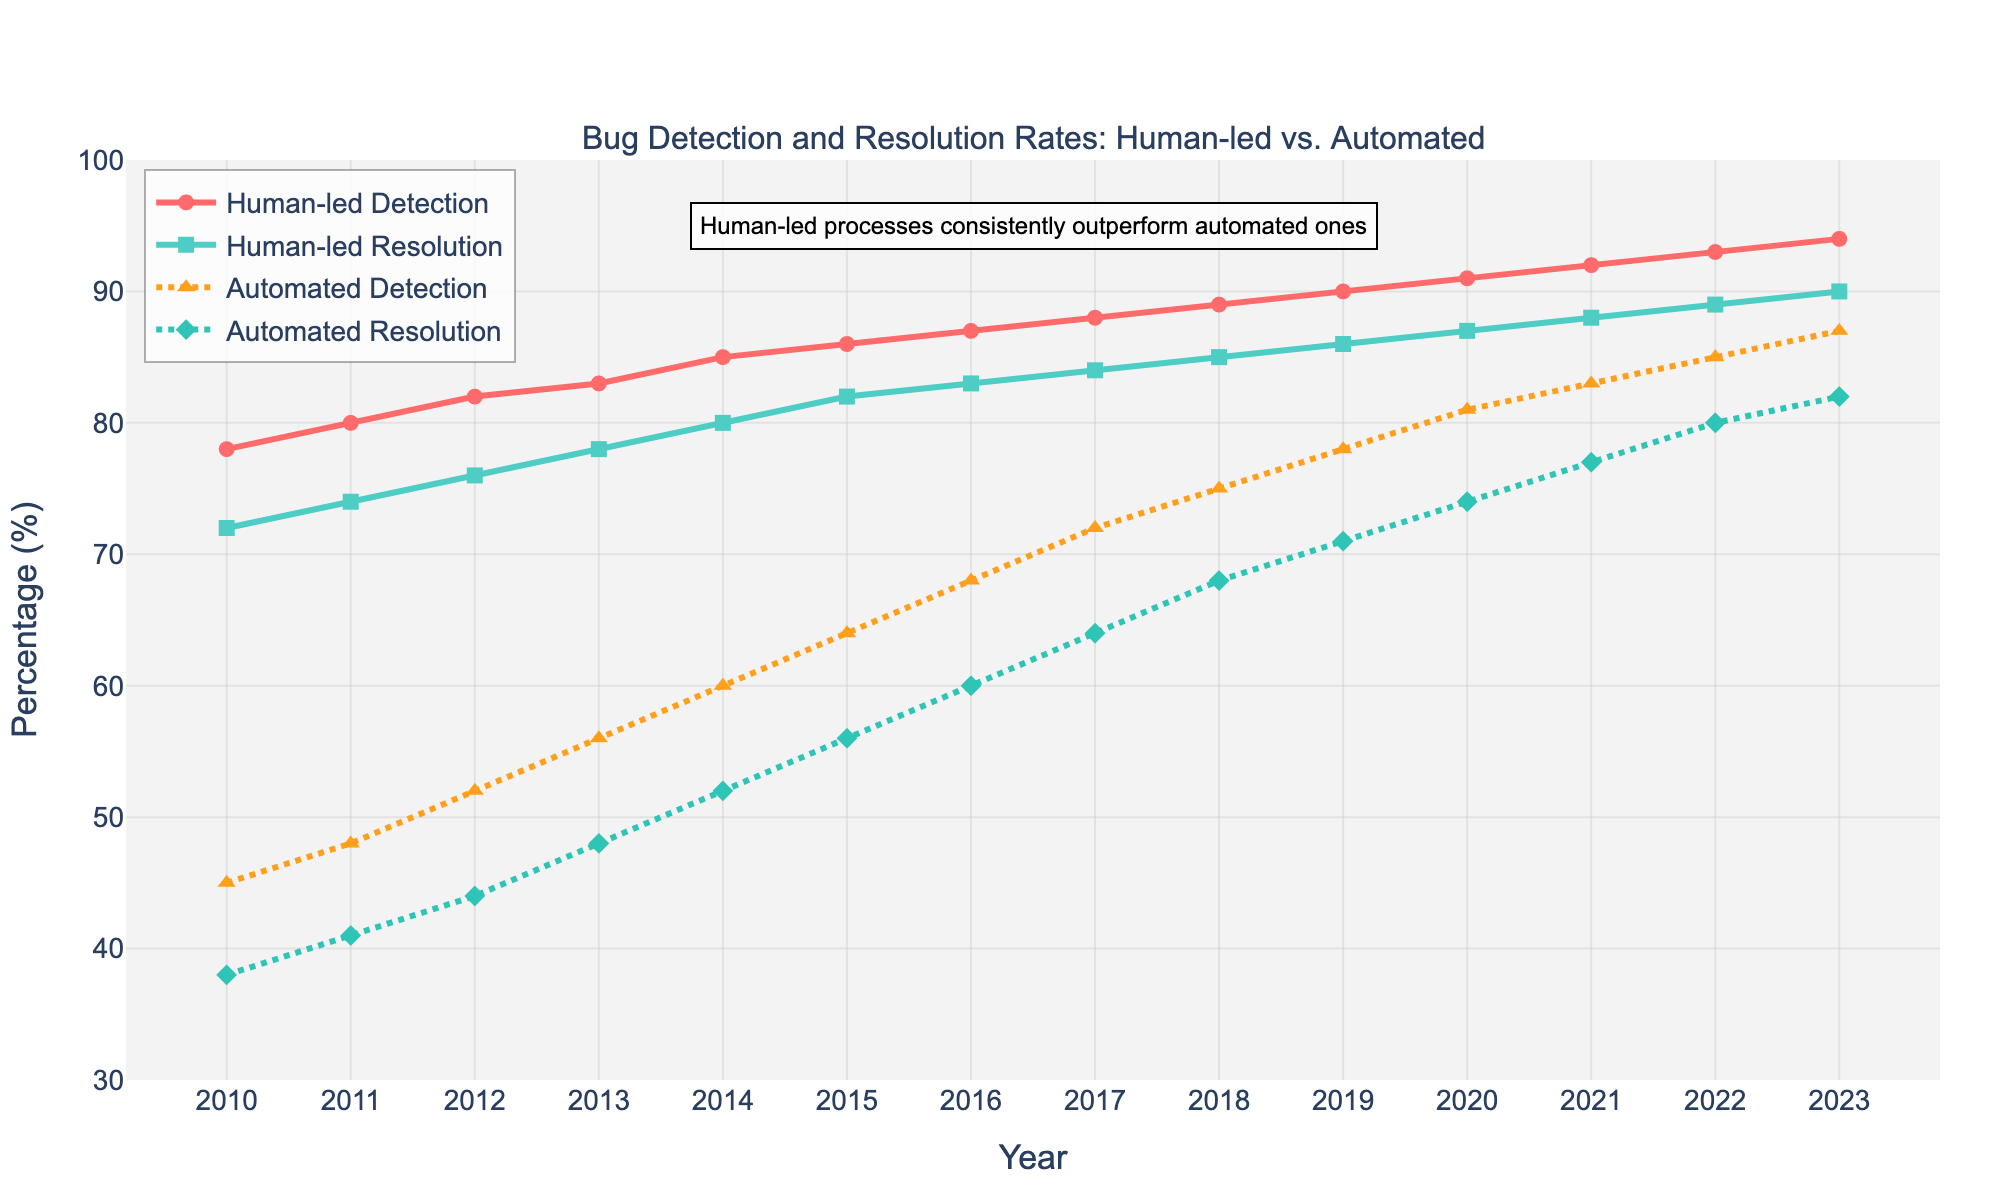How does the human-led bug detection rate in 2010 compare to 2015? Look at the points for human-led bug detection in 2010 and 2015. In 2010 it's 78%, and in 2015 it's 86%. Subtract the 2010 value from the 2015 value: 86% - 78% = 8%.
Answer: 8% Which year did automated bug resolution surpass 50%? Track the line representing automated bug resolution. It crosses 50% between 2014 and 2015, reaching exactly 56% in 2015.
Answer: 2015 What is the combined detection rate (human-led + automated) in 2020? Look at the detection rates for both human-led and automated processes in 2020. Human-led is 91%, and automated is 81%. Add them together: 91% + 81% = 172%.
Answer: 172% Between 2010 and 2023, in which year did the human-led bug resolution rate equal the automated bug detection rate? Compare human-led bug resolution and automated bug detection values across the years. In 2022, both rates are equal at 85%.
Answer: 2022 By how much did the automated bug detection rate improve from 2010 to 2023? Note the values for automated bug detection in 2010 (45%) and 2023 (87%). Calculate the increase: 87% - 45% = 42%.
Answer: 42% Describe the color and visual style used for tracing human-led bug resolution. The human-led bug resolution is represented by a solid line with square markers and is colored in green.
Answer: Green, solid line, square markers In which year did human-led processes reach 90% in both detection and resolution? Check when both human-led detection and resolution lines cross the 90% mark. It happens in 2023 for detection and 2022 for resolution. They don't match in the same year.
Answer: Never Which process had a higher detection rate in 2016, human-led or automated? In 2016, look at the values for both human-led detection (87%) and automated detection (68%). Human-led is higher.
Answer: Human-led What is the average bug resolution rate for automated processes over the years 2010 to 2013? Find automated bug resolution rates for 2010 (38%), 2011 (41%), 2012 (44%), and 2013 (48%). Sum them: 38 + 41 + 44 + 48 = 171. Take the average: 171 / 4 = 42.75%.
Answer: 42.75% How does the change in human-led detection rate from 2011 to 2021 compare to the change in automated detection rate over the same period? Calculate the increase in human-led detection from 2011 (80%) to 2021 (92%): 92% - 80% = 12%. For automated detection from 2011 (48%) to 2021 (83%): 83% - 48% = 35%. Compare the two changes.
Answer: Human-led: 12%, Automated: 35% 